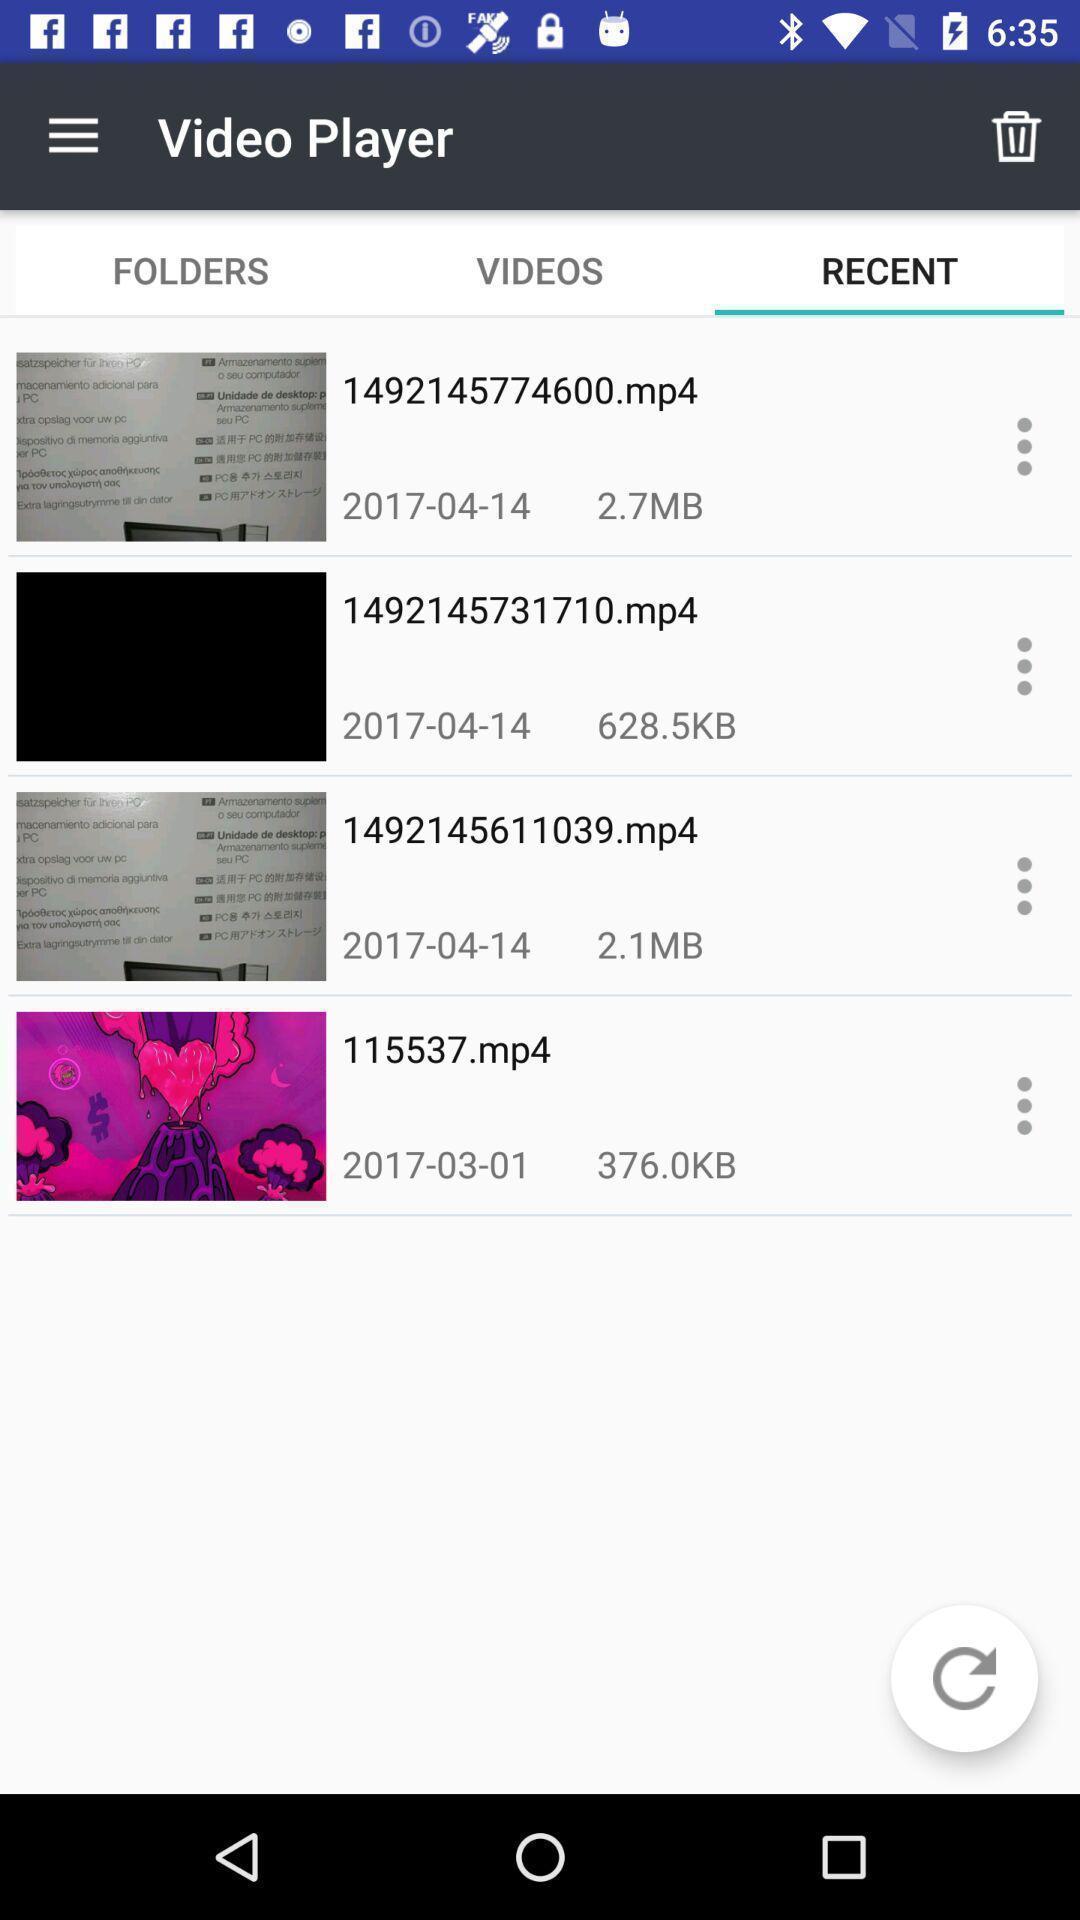Please provide a description for this image. Screen shows videos of recent video player app. 